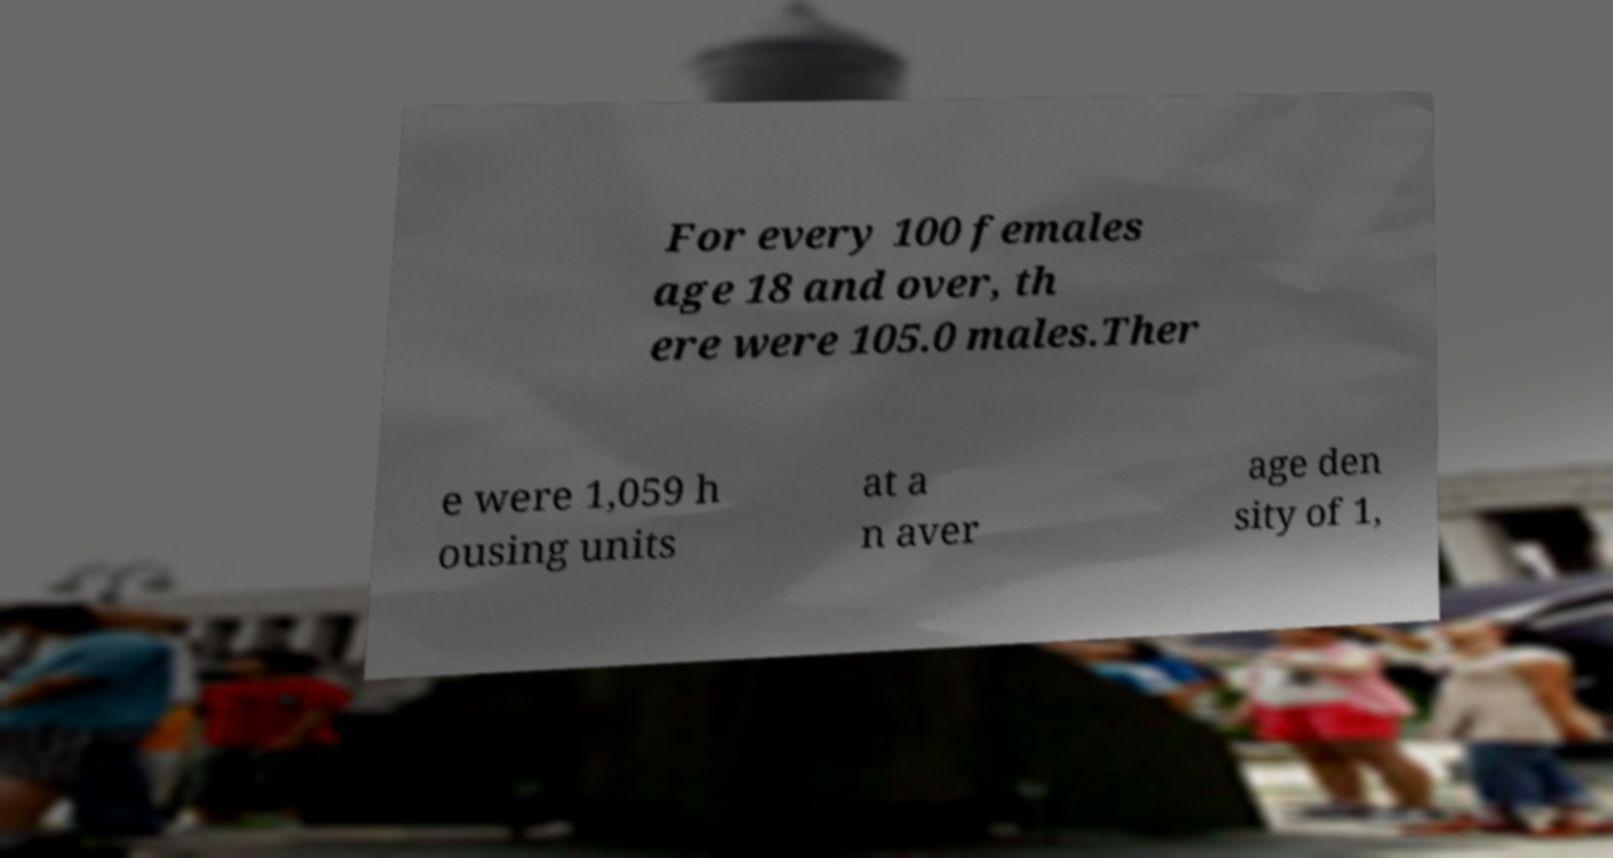For documentation purposes, I need the text within this image transcribed. Could you provide that? For every 100 females age 18 and over, th ere were 105.0 males.Ther e were 1,059 h ousing units at a n aver age den sity of 1, 